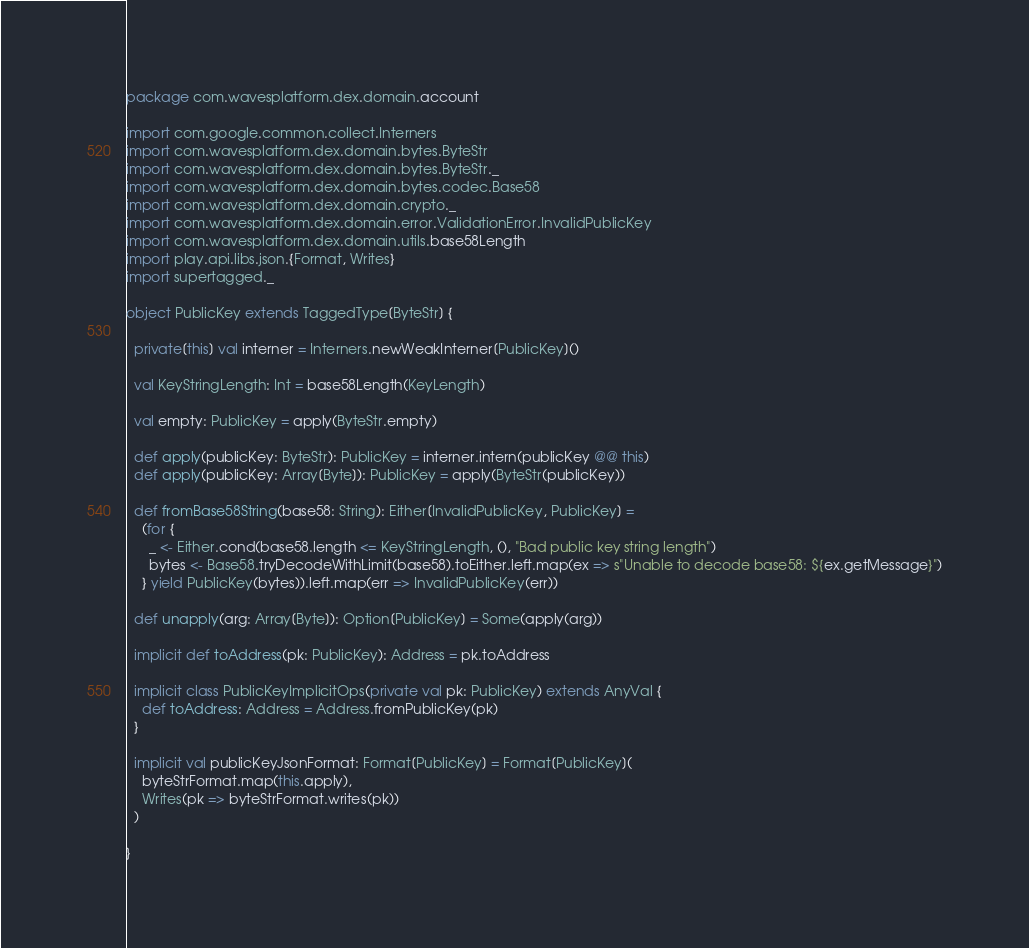Convert code to text. <code><loc_0><loc_0><loc_500><loc_500><_Scala_>package com.wavesplatform.dex.domain.account

import com.google.common.collect.Interners
import com.wavesplatform.dex.domain.bytes.ByteStr
import com.wavesplatform.dex.domain.bytes.ByteStr._
import com.wavesplatform.dex.domain.bytes.codec.Base58
import com.wavesplatform.dex.domain.crypto._
import com.wavesplatform.dex.domain.error.ValidationError.InvalidPublicKey
import com.wavesplatform.dex.domain.utils.base58Length
import play.api.libs.json.{Format, Writes}
import supertagged._

object PublicKey extends TaggedType[ByteStr] {

  private[this] val interner = Interners.newWeakInterner[PublicKey]()

  val KeyStringLength: Int = base58Length(KeyLength)

  val empty: PublicKey = apply(ByteStr.empty)

  def apply(publicKey: ByteStr): PublicKey = interner.intern(publicKey @@ this)
  def apply(publicKey: Array[Byte]): PublicKey = apply(ByteStr(publicKey))

  def fromBase58String(base58: String): Either[InvalidPublicKey, PublicKey] =
    (for {
      _ <- Either.cond(base58.length <= KeyStringLength, (), "Bad public key string length")
      bytes <- Base58.tryDecodeWithLimit(base58).toEither.left.map(ex => s"Unable to decode base58: ${ex.getMessage}")
    } yield PublicKey(bytes)).left.map(err => InvalidPublicKey(err))

  def unapply(arg: Array[Byte]): Option[PublicKey] = Some(apply(arg))

  implicit def toAddress(pk: PublicKey): Address = pk.toAddress

  implicit class PublicKeyImplicitOps(private val pk: PublicKey) extends AnyVal {
    def toAddress: Address = Address.fromPublicKey(pk)
  }

  implicit val publicKeyJsonFormat: Format[PublicKey] = Format[PublicKey](
    byteStrFormat.map(this.apply),
    Writes(pk => byteStrFormat.writes(pk))
  )

}
</code> 